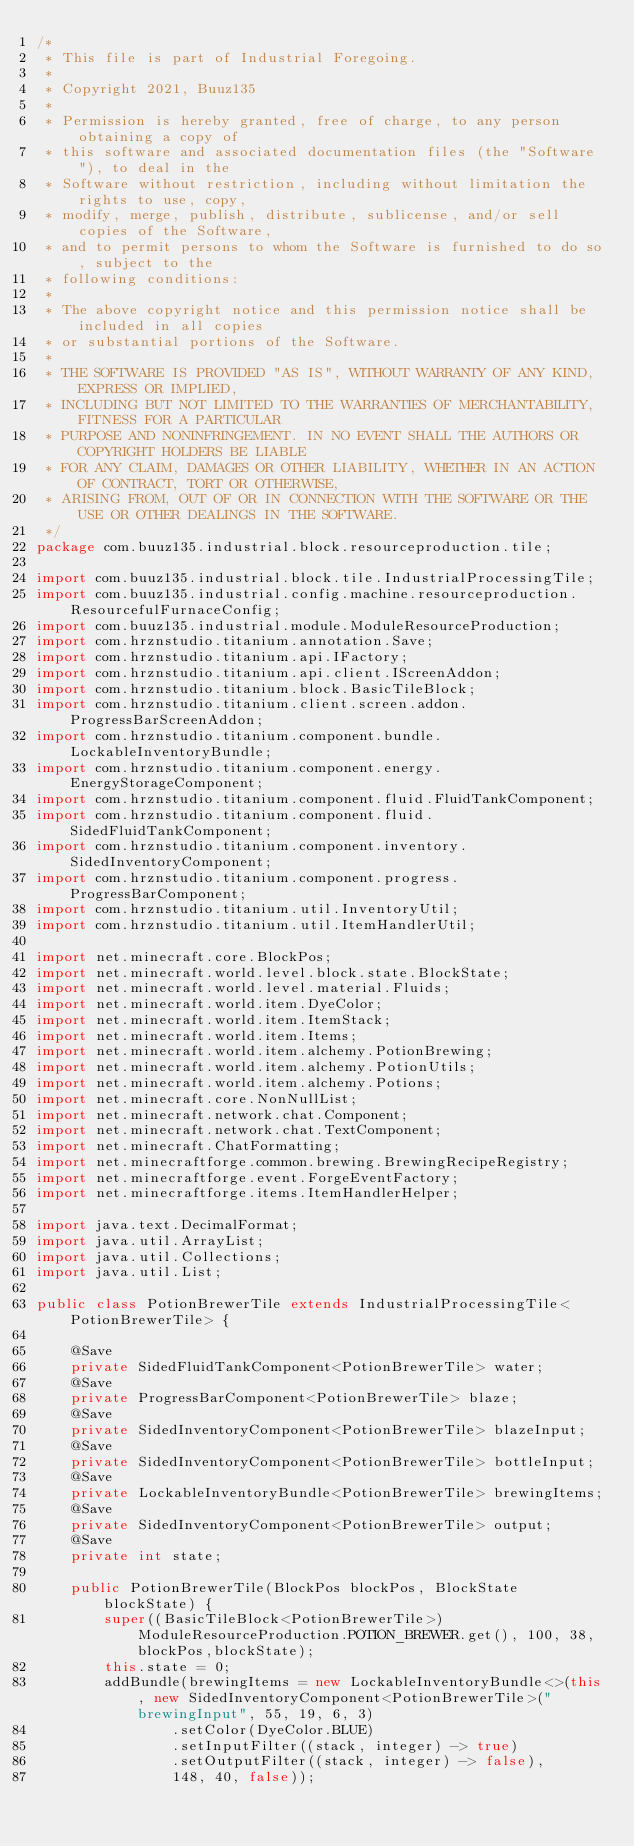<code> <loc_0><loc_0><loc_500><loc_500><_Java_>/*
 * This file is part of Industrial Foregoing.
 *
 * Copyright 2021, Buuz135
 *
 * Permission is hereby granted, free of charge, to any person obtaining a copy of
 * this software and associated documentation files (the "Software"), to deal in the
 * Software without restriction, including without limitation the rights to use, copy,
 * modify, merge, publish, distribute, sublicense, and/or sell copies of the Software,
 * and to permit persons to whom the Software is furnished to do so, subject to the
 * following conditions:
 *
 * The above copyright notice and this permission notice shall be included in all copies
 * or substantial portions of the Software.
 *
 * THE SOFTWARE IS PROVIDED "AS IS", WITHOUT WARRANTY OF ANY KIND, EXPRESS OR IMPLIED,
 * INCLUDING BUT NOT LIMITED TO THE WARRANTIES OF MERCHANTABILITY, FITNESS FOR A PARTICULAR
 * PURPOSE AND NONINFRINGEMENT. IN NO EVENT SHALL THE AUTHORS OR COPYRIGHT HOLDERS BE LIABLE
 * FOR ANY CLAIM, DAMAGES OR OTHER LIABILITY, WHETHER IN AN ACTION OF CONTRACT, TORT OR OTHERWISE,
 * ARISING FROM, OUT OF OR IN CONNECTION WITH THE SOFTWARE OR THE USE OR OTHER DEALINGS IN THE SOFTWARE.
 */
package com.buuz135.industrial.block.resourceproduction.tile;

import com.buuz135.industrial.block.tile.IndustrialProcessingTile;
import com.buuz135.industrial.config.machine.resourceproduction.ResourcefulFurnaceConfig;
import com.buuz135.industrial.module.ModuleResourceProduction;
import com.hrznstudio.titanium.annotation.Save;
import com.hrznstudio.titanium.api.IFactory;
import com.hrznstudio.titanium.api.client.IScreenAddon;
import com.hrznstudio.titanium.block.BasicTileBlock;
import com.hrznstudio.titanium.client.screen.addon.ProgressBarScreenAddon;
import com.hrznstudio.titanium.component.bundle.LockableInventoryBundle;
import com.hrznstudio.titanium.component.energy.EnergyStorageComponent;
import com.hrznstudio.titanium.component.fluid.FluidTankComponent;
import com.hrznstudio.titanium.component.fluid.SidedFluidTankComponent;
import com.hrznstudio.titanium.component.inventory.SidedInventoryComponent;
import com.hrznstudio.titanium.component.progress.ProgressBarComponent;
import com.hrznstudio.titanium.util.InventoryUtil;
import com.hrznstudio.titanium.util.ItemHandlerUtil;

import net.minecraft.core.BlockPos;
import net.minecraft.world.level.block.state.BlockState;
import net.minecraft.world.level.material.Fluids;
import net.minecraft.world.item.DyeColor;
import net.minecraft.world.item.ItemStack;
import net.minecraft.world.item.Items;
import net.minecraft.world.item.alchemy.PotionBrewing;
import net.minecraft.world.item.alchemy.PotionUtils;
import net.minecraft.world.item.alchemy.Potions;
import net.minecraft.core.NonNullList;
import net.minecraft.network.chat.Component;
import net.minecraft.network.chat.TextComponent;
import net.minecraft.ChatFormatting;
import net.minecraftforge.common.brewing.BrewingRecipeRegistry;
import net.minecraftforge.event.ForgeEventFactory;
import net.minecraftforge.items.ItemHandlerHelper;

import java.text.DecimalFormat;
import java.util.ArrayList;
import java.util.Collections;
import java.util.List;

public class PotionBrewerTile extends IndustrialProcessingTile<PotionBrewerTile> {

    @Save
    private SidedFluidTankComponent<PotionBrewerTile> water;
    @Save
    private ProgressBarComponent<PotionBrewerTile> blaze;
    @Save
    private SidedInventoryComponent<PotionBrewerTile> blazeInput;
    @Save
    private SidedInventoryComponent<PotionBrewerTile> bottleInput;
    @Save
    private LockableInventoryBundle<PotionBrewerTile> brewingItems;
    @Save
    private SidedInventoryComponent<PotionBrewerTile> output;
    @Save
    private int state;

    public PotionBrewerTile(BlockPos blockPos, BlockState blockState) {
        super((BasicTileBlock<PotionBrewerTile>) ModuleResourceProduction.POTION_BREWER.get(), 100, 38, blockPos,blockState);
        this.state = 0;
        addBundle(brewingItems = new LockableInventoryBundle<>(this, new SidedInventoryComponent<PotionBrewerTile>("brewingInput", 55, 19, 6, 3)
                .setColor(DyeColor.BLUE)
                .setInputFilter((stack, integer) -> true)
                .setOutputFilter((stack, integer) -> false),
                148, 40, false));</code> 